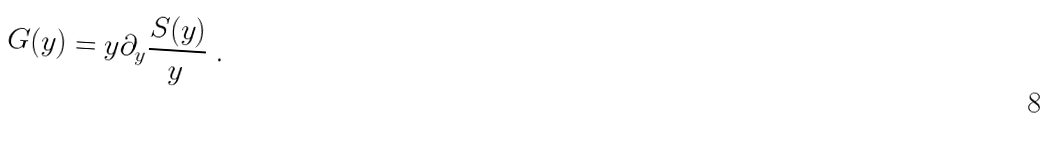<formula> <loc_0><loc_0><loc_500><loc_500>G ( y ) = y \partial _ { y } \frac { S ( y ) } { y } \ .</formula> 